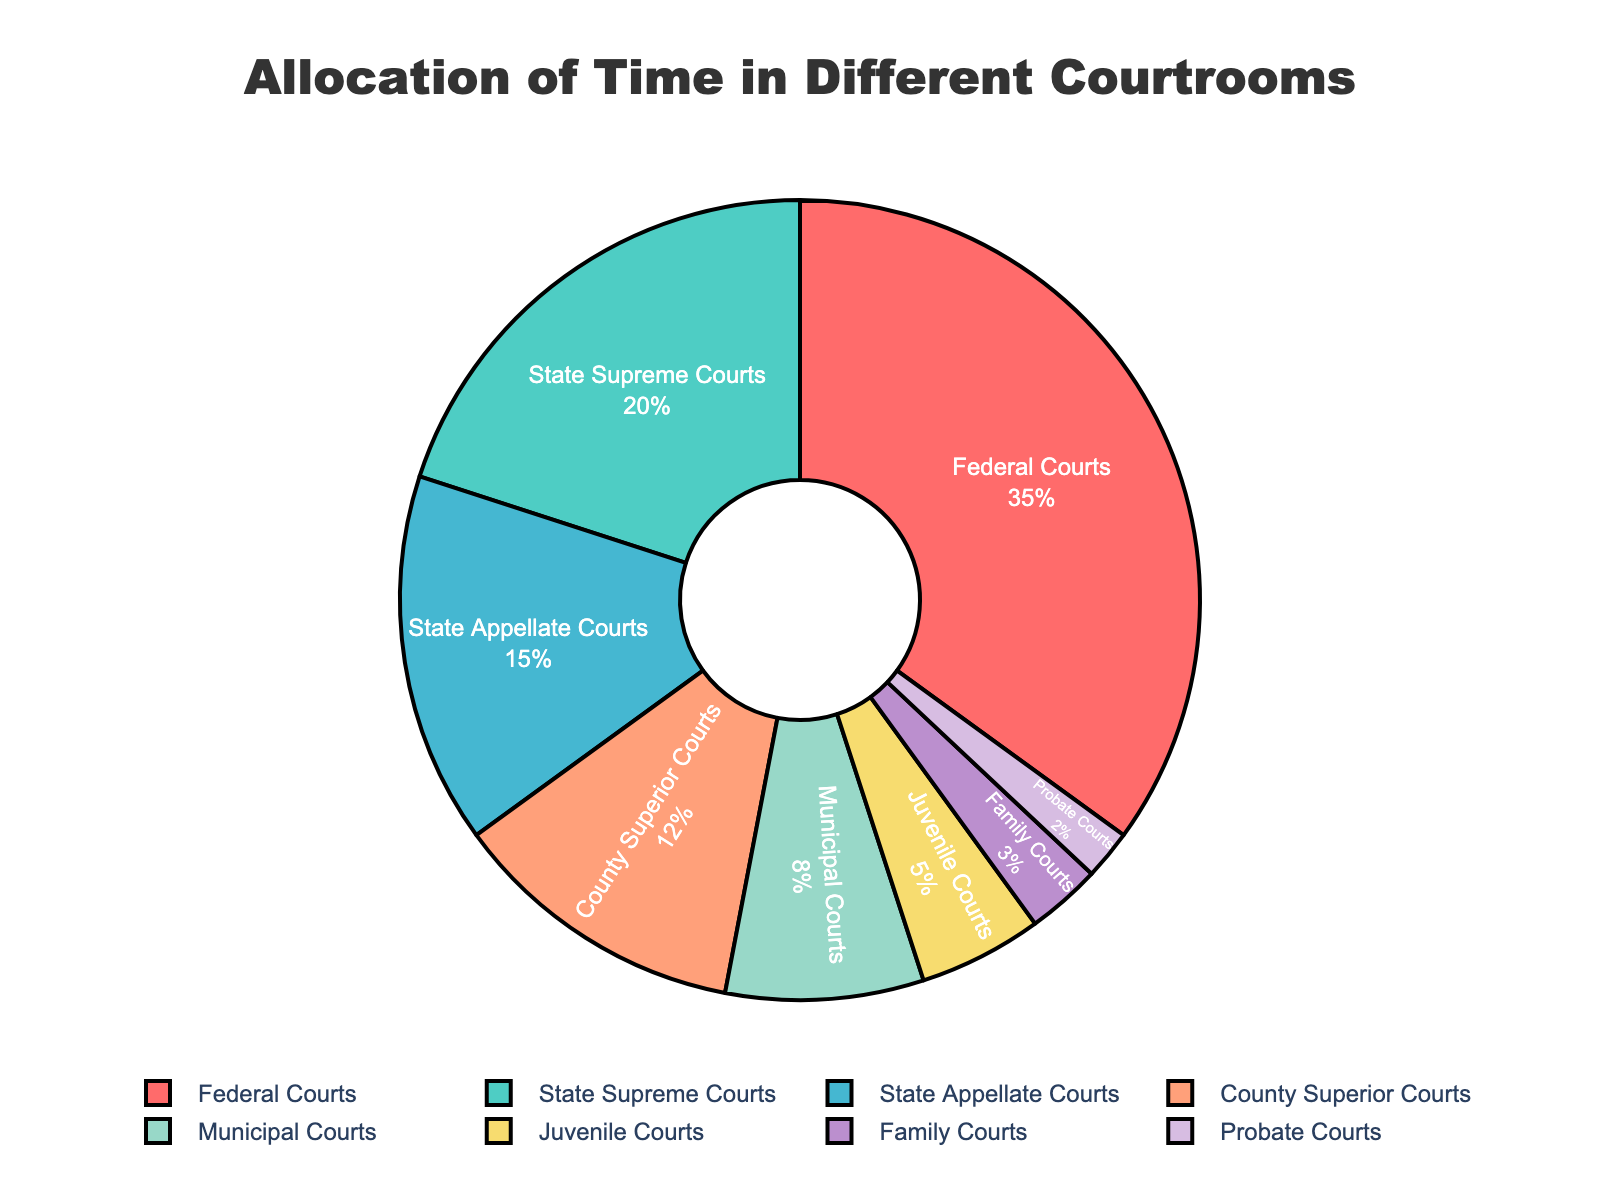Which type of court is allocated the most time? By looking at the largest section of the pie chart, we can see that Federal Courts occupy the largest share.
Answer: Federal Courts What is the sum of time spent in both State Supreme Courts and State Appellate Courts? The percentages for State Supreme Courts and State Appellate Courts are 20% and 15%, respectively. Adding them together gives us 20 + 15 = 35%.
Answer: 35% Which type of court has a higher percentage: County Superior Courts or Municipal Courts? Comparing the percentages, County Superior Courts have 12% while Municipal Courts have 8%. 12% is higher than 8%.
Answer: County Superior Courts What is the difference between the time spent in Juvenile Courts and Family Courts? Juvenile Courts have 5% and Family Courts have 3%. Subtracting these gives us 5 - 3 = 2%.
Answer: 2% Identify the type of courts with the least and the most time allocation and state the difference in their percentages. The court with the most time is Federal Courts with 35%, and the one with the least is Probate Courts with 2%. The difference is 35 - 2 = 33%.
Answer: 33% Which court type takes up a bright red section of the pie chart and what percentage of time does it represent? The pie chart's bright red section corresponds to the Federal Courts. According to the chart, Federal Courts represent 35% of the total time.
Answer: Federal Courts, 35% How does the time allocated to Municipal Courts compare to the combined time spent in Juvenile and Family Courts? Municipal Courts have 8%. Juvenile Courts and Family Courts combined have 5% + 3% = 8%. They are equal.
Answer: Equal What is the combined percentage of time spent in the Municipal, Juvenile, Family, and Probate Courts? The percentages are 8% for Municipal, 5% for Juvenile, 3% for Family, and 2% for Probate. Adding them together, we have 8 + 5 + 3 + 2 = 18%.
Answer: 18% What is the share of time dedicated to courts that have more than 10% allocation each? Federal Courts (35%), State Supreme Courts (20%), and State Appellate Courts (15%) each have more than 10%. The combined percentage is 35 + 20 + 15 = 70%.
Answer: 70% What fraction of the total time is spent in Federal and State Supreme Courts together? Federal Courts account for 35% and State Supreme Courts 20%. Adding these gives us 35 + 20 = 55%. This is equal to 55/100 or 11/20 of the total time.
Answer: 11/20 